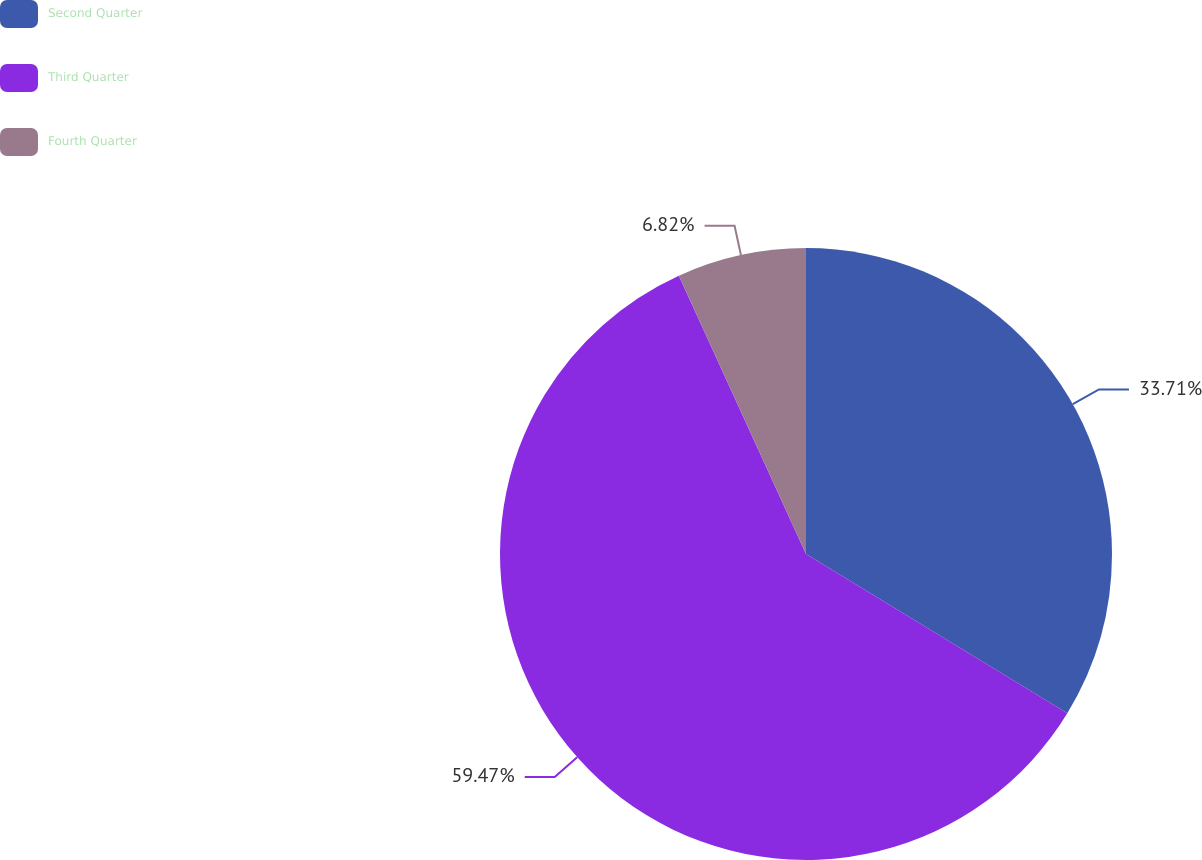Convert chart. <chart><loc_0><loc_0><loc_500><loc_500><pie_chart><fcel>Second Quarter<fcel>Third Quarter<fcel>Fourth Quarter<nl><fcel>33.71%<fcel>59.47%<fcel>6.82%<nl></chart> 